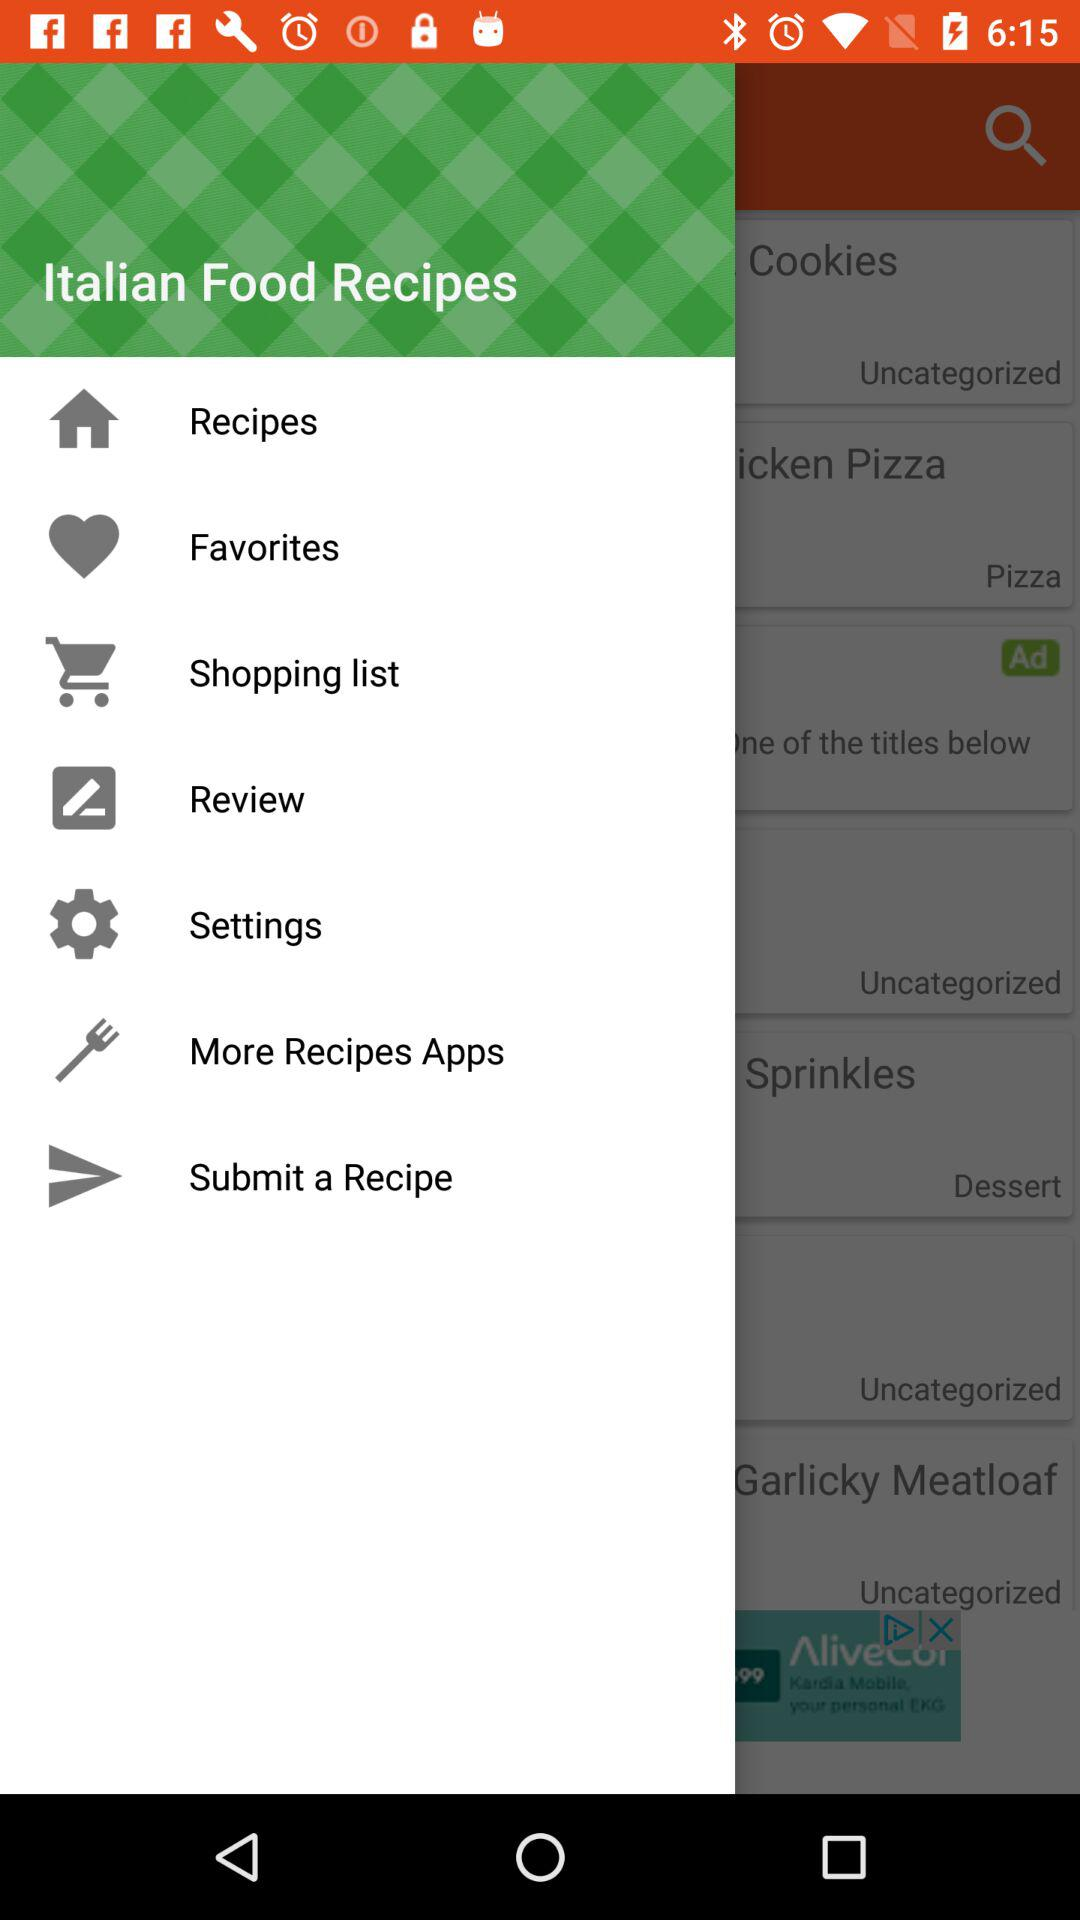What is the application name? The application name is "Italian Food Recipes". 